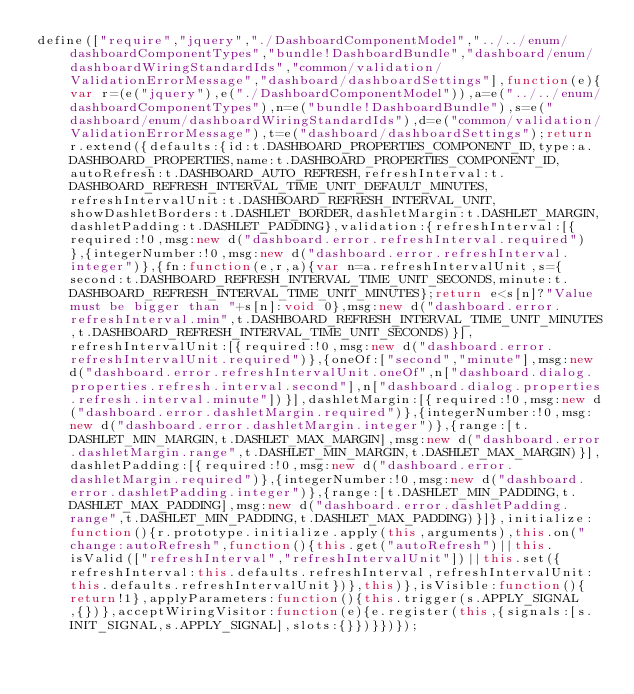<code> <loc_0><loc_0><loc_500><loc_500><_JavaScript_>define(["require","jquery","./DashboardComponentModel","../../enum/dashboardComponentTypes","bundle!DashboardBundle","dashboard/enum/dashboardWiringStandardIds","common/validation/ValidationErrorMessage","dashboard/dashboardSettings"],function(e){var r=(e("jquery"),e("./DashboardComponentModel")),a=e("../../enum/dashboardComponentTypes"),n=e("bundle!DashboardBundle"),s=e("dashboard/enum/dashboardWiringStandardIds"),d=e("common/validation/ValidationErrorMessage"),t=e("dashboard/dashboardSettings");return r.extend({defaults:{id:t.DASHBOARD_PROPERTIES_COMPONENT_ID,type:a.DASHBOARD_PROPERTIES,name:t.DASHBOARD_PROPERTIES_COMPONENT_ID,autoRefresh:t.DASHBOARD_AUTO_REFRESH,refreshInterval:t.DASHBOARD_REFRESH_INTERVAL_TIME_UNIT_DEFAULT_MINUTES,refreshIntervalUnit:t.DASHBOARD_REFRESH_INTERVAL_UNIT,showDashletBorders:t.DASHLET_BORDER,dashletMargin:t.DASHLET_MARGIN,dashletPadding:t.DASHLET_PADDING},validation:{refreshInterval:[{required:!0,msg:new d("dashboard.error.refreshInterval.required")},{integerNumber:!0,msg:new d("dashboard.error.refreshInterval.integer")},{fn:function(e,r,a){var n=a.refreshIntervalUnit,s={second:t.DASHBOARD_REFRESH_INTERVAL_TIME_UNIT_SECONDS,minute:t.DASHBOARD_REFRESH_INTERVAL_TIME_UNIT_MINUTES};return e<s[n]?"Value must be bigger than "+s[n]:void 0},msg:new d("dashboard.error.refreshInterval.min",t.DASHBOARD_REFRESH_INTERVAL_TIME_UNIT_MINUTES,t.DASHBOARD_REFRESH_INTERVAL_TIME_UNIT_SECONDS)}],refreshIntervalUnit:[{required:!0,msg:new d("dashboard.error.refreshIntervalUnit.required")},{oneOf:["second","minute"],msg:new d("dashboard.error.refreshIntervalUnit.oneOf",n["dashboard.dialog.properties.refresh.interval.second"],n["dashboard.dialog.properties.refresh.interval.minute"])}],dashletMargin:[{required:!0,msg:new d("dashboard.error.dashletMargin.required")},{integerNumber:!0,msg:new d("dashboard.error.dashletMargin.integer")},{range:[t.DASHLET_MIN_MARGIN,t.DASHLET_MAX_MARGIN],msg:new d("dashboard.error.dashletMargin.range",t.DASHLET_MIN_MARGIN,t.DASHLET_MAX_MARGIN)}],dashletPadding:[{required:!0,msg:new d("dashboard.error.dashletMargin.required")},{integerNumber:!0,msg:new d("dashboard.error.dashletPadding.integer")},{range:[t.DASHLET_MIN_PADDING,t.DASHLET_MAX_PADDING],msg:new d("dashboard.error.dashletPadding.range",t.DASHLET_MIN_PADDING,t.DASHLET_MAX_PADDING)}]},initialize:function(){r.prototype.initialize.apply(this,arguments),this.on("change:autoRefresh",function(){this.get("autoRefresh")||this.isValid(["refreshInterval","refreshIntervalUnit"])||this.set({refreshInterval:this.defaults.refreshInterval,refreshIntervalUnit:this.defaults.refreshIntervalUnit})},this)},isVisible:function(){return!1},applyParameters:function(){this.trigger(s.APPLY_SIGNAL,{})},acceptWiringVisitor:function(e){e.register(this,{signals:[s.INIT_SIGNAL,s.APPLY_SIGNAL],slots:{}})}})});</code> 